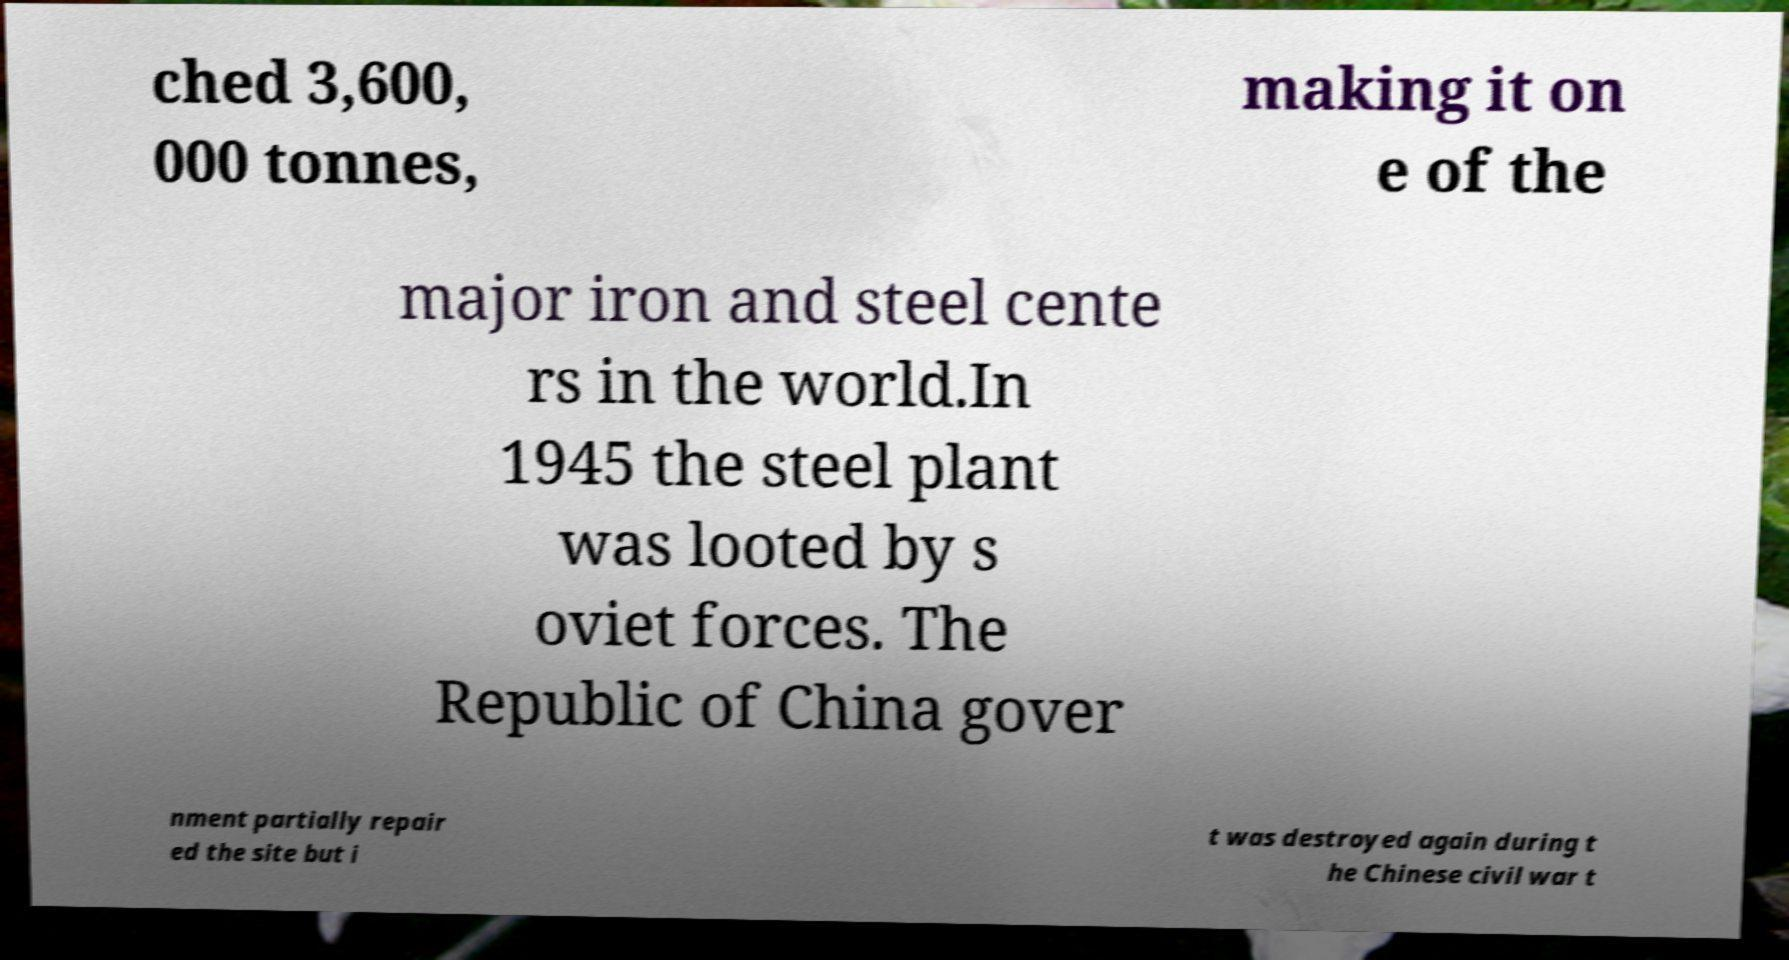Could you extract and type out the text from this image? ched 3,600, 000 tonnes, making it on e of the major iron and steel cente rs in the world.In 1945 the steel plant was looted by s oviet forces. The Republic of China gover nment partially repair ed the site but i t was destroyed again during t he Chinese civil war t 